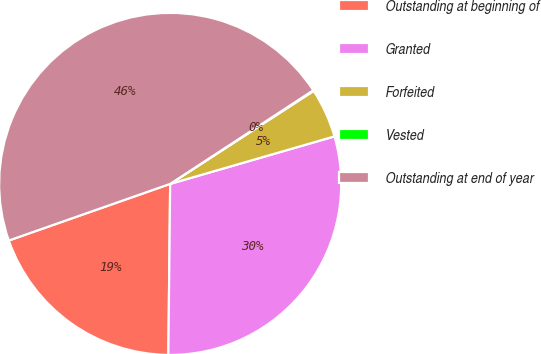Convert chart to OTSL. <chart><loc_0><loc_0><loc_500><loc_500><pie_chart><fcel>Outstanding at beginning of<fcel>Granted<fcel>Forfeited<fcel>Vested<fcel>Outstanding at end of year<nl><fcel>19.46%<fcel>29.65%<fcel>4.67%<fcel>0.07%<fcel>46.15%<nl></chart> 